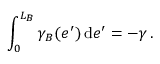Convert formula to latex. <formula><loc_0><loc_0><loc_500><loc_500>\int _ { 0 } ^ { L _ { B } } \gamma _ { B } ( e ^ { \prime } ) \, d e ^ { \prime } = - \gamma \, .</formula> 